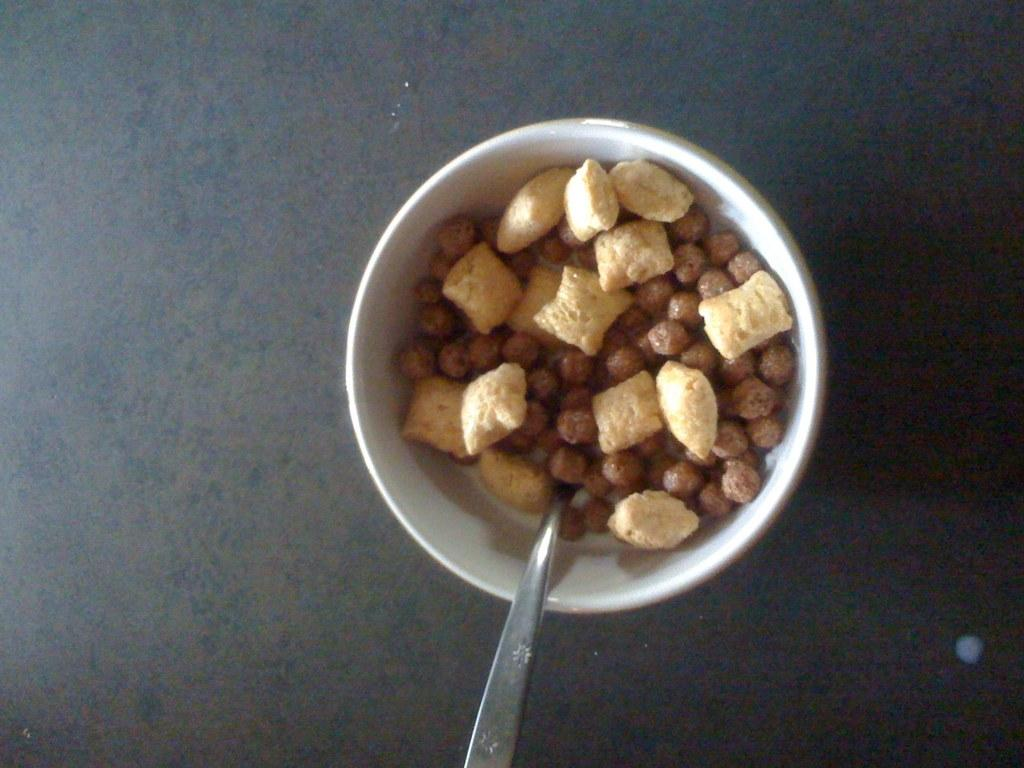What is in the bowl that is visible in the image? The bowl contains nuts in the image. What object might be used to scoop or stir the nuts in the bowl? There is a spoon in the image that could be used for that purpose. Where is the spoon located in the image? The spoon is placed on a table in the image. What type of stone can be seen reciting a verse in the image? There is no stone or verse present in the image; it only features a bowl of nuts and a spoon on a table. 